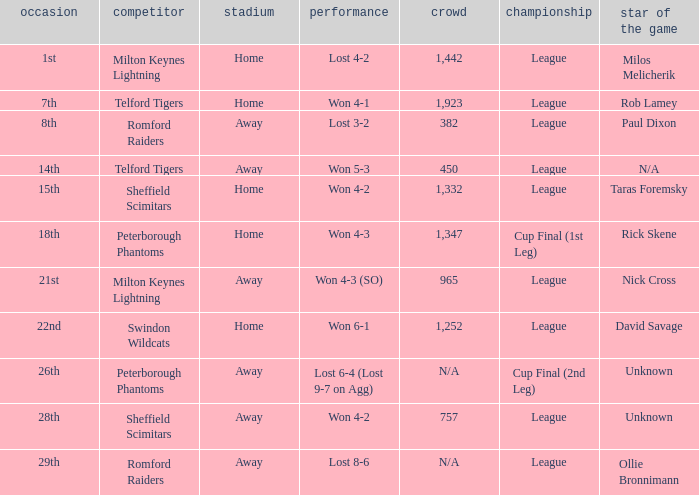Who was the Man of the Match when the opponent was Milton Keynes Lightning and the venue was Away? Nick Cross. 